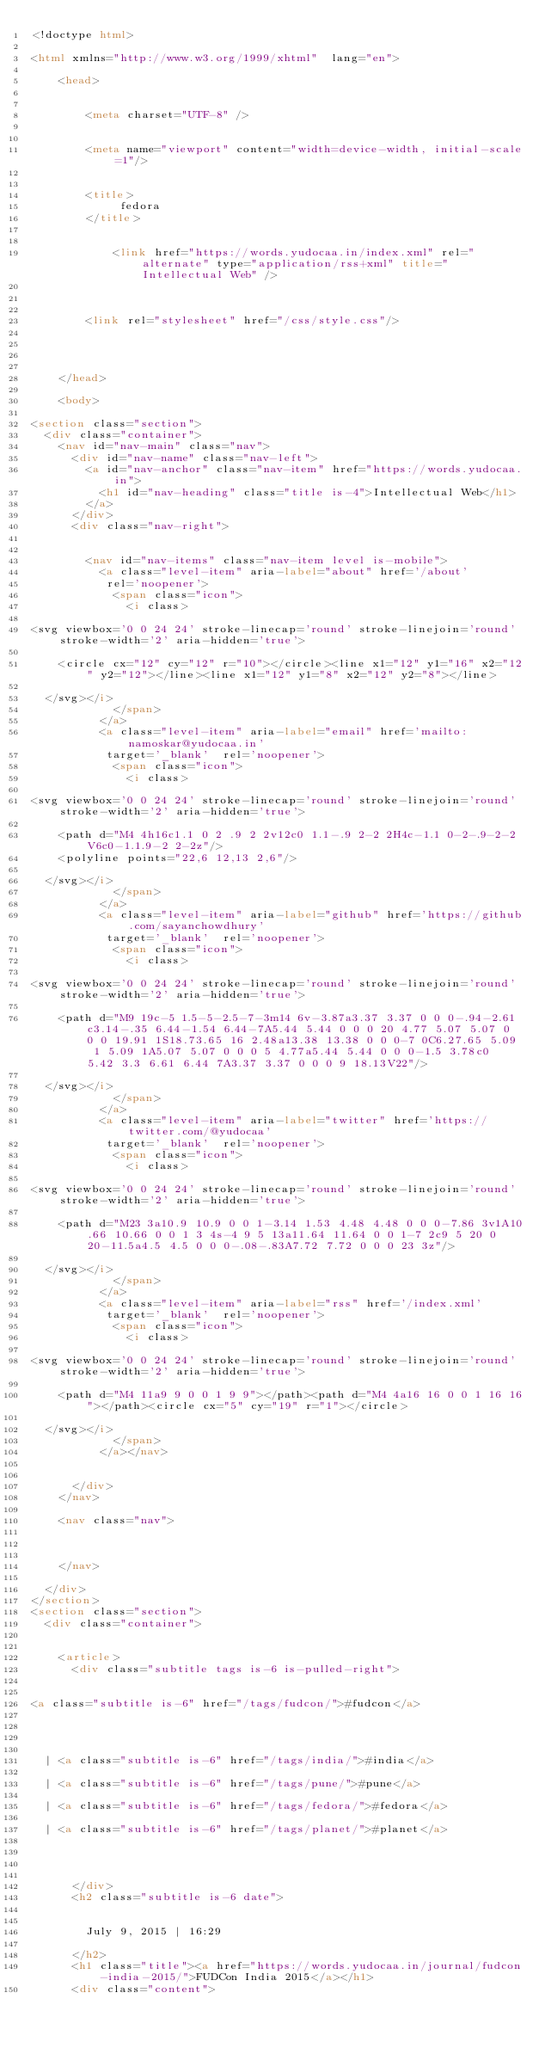<code> <loc_0><loc_0><loc_500><loc_500><_HTML_><!doctype html>

<html xmlns="http://www.w3.org/1999/xhtml"  lang="en">

    <head>

        
        <meta charset="UTF-8" />

        
        <meta name="viewport" content="width=device-width, initial-scale=1"/>

                
        <title> 
             fedora  
        </title>
        
        
            <link href="https://words.yudocaa.in/index.xml" rel="alternate" type="application/rss+xml" title="Intellectual Web" />
        

        
        <link rel="stylesheet" href="/css/style.css"/>

        
        
        
    </head>

    <body>

<section class="section">
  <div class="container">
    <nav id="nav-main" class="nav">
      <div id="nav-name" class="nav-left">
        <a id="nav-anchor" class="nav-item" href="https://words.yudocaa.in">
          <h1 id="nav-heading" class="title is-4">Intellectual Web</h1>
        </a>
      </div>
      <div class="nav-right">
        
        
        <nav id="nav-items" class="nav-item level is-mobile">
          <a class="level-item" aria-label="about" href='/about'
           rel='noopener'>
            <span class="icon">
              <i class>

<svg viewbox='0 0 24 24' stroke-linecap='round' stroke-linejoin='round' stroke-width='2' aria-hidden='true'>
    
    <circle cx="12" cy="12" r="10"></circle><line x1="12" y1="16" x2="12" y2="12"></line><line x1="12" y1="8" x2="12" y2="8"></line>
    
  </svg></i>
            </span>
          </a>
          <a class="level-item" aria-label="email" href='mailto:namoskar@yudocaa.in'
           target='_blank'  rel='noopener'>
            <span class="icon">
              <i class>

<svg viewbox='0 0 24 24' stroke-linecap='round' stroke-linejoin='round' stroke-width='2' aria-hidden='true'>
    
    <path d="M4 4h16c1.1 0 2 .9 2 2v12c0 1.1-.9 2-2 2H4c-1.1 0-2-.9-2-2V6c0-1.1.9-2 2-2z"/>
    <polyline points="22,6 12,13 2,6"/>
    
  </svg></i>
            </span>
          </a>
          <a class="level-item" aria-label="github" href='https://github.com/sayanchowdhury'
           target='_blank'  rel='noopener'>
            <span class="icon">
              <i class>

<svg viewbox='0 0 24 24' stroke-linecap='round' stroke-linejoin='round' stroke-width='2' aria-hidden='true'>
    
    <path d="M9 19c-5 1.5-5-2.5-7-3m14 6v-3.87a3.37 3.37 0 0 0-.94-2.61c3.14-.35 6.44-1.54 6.44-7A5.44 5.44 0 0 0 20 4.77 5.07 5.07 0 0 0 19.91 1S18.73.65 16 2.48a13.38 13.38 0 0 0-7 0C6.27.65 5.09 1 5.09 1A5.07 5.07 0 0 0 5 4.77a5.44 5.44 0 0 0-1.5 3.78c0 5.42 3.3 6.61 6.44 7A3.37 3.37 0 0 0 9 18.13V22"/>
    
  </svg></i>
            </span>
          </a>
          <a class="level-item" aria-label="twitter" href='https://twitter.com/@yudocaa'
           target='_blank'  rel='noopener'>
            <span class="icon">
              <i class>

<svg viewbox='0 0 24 24' stroke-linecap='round' stroke-linejoin='round' stroke-width='2' aria-hidden='true'>
    
    <path d="M23 3a10.9 10.9 0 0 1-3.14 1.53 4.48 4.48 0 0 0-7.86 3v1A10.66 10.66 0 0 1 3 4s-4 9 5 13a11.64 11.64 0 0 1-7 2c9 5 20 0 20-11.5a4.5 4.5 0 0 0-.08-.83A7.72 7.72 0 0 0 23 3z"/>
    
  </svg></i>
            </span>
          </a>
          <a class="level-item" aria-label="rss" href='/index.xml'
           target='_blank'  rel='noopener'>
            <span class="icon">
              <i class>

<svg viewbox='0 0 24 24' stroke-linecap='round' stroke-linejoin='round' stroke-width='2' aria-hidden='true'>
    
    <path d="M4 11a9 9 0 0 1 9 9"></path><path d="M4 4a16 16 0 0 1 16 16"></path><circle cx="5" cy="19" r="1"></circle>
    
  </svg></i>
            </span>
          </a></nav>
        
      
      </div>
    </nav>

    <nav class="nav">
      

      
    </nav>

  </div>
</section>
<section class="section">
  <div class="container">
    
    
    <article>
      <div class="subtitle tags is-6 is-pulled-right">
        
        
<a class="subtitle is-6" href="/tags/fudcon/">#fudcon</a>



  
  | <a class="subtitle is-6" href="/tags/india/">#india</a>
  
  | <a class="subtitle is-6" href="/tags/pune/">#pune</a>
  
  | <a class="subtitle is-6" href="/tags/fedora/">#fedora</a>
  
  | <a class="subtitle is-6" href="/tags/planet/">#planet</a>
  


        
      </div>
      <h2 class="subtitle is-6 date">
        
    
        July 9, 2015 | 16:29
    
      </h2>
      <h1 class="title"><a href="https://words.yudocaa.in/journal/fudcon-india-2015/">FUDCon India 2015</a></h1>
      <div class="content"></code> 